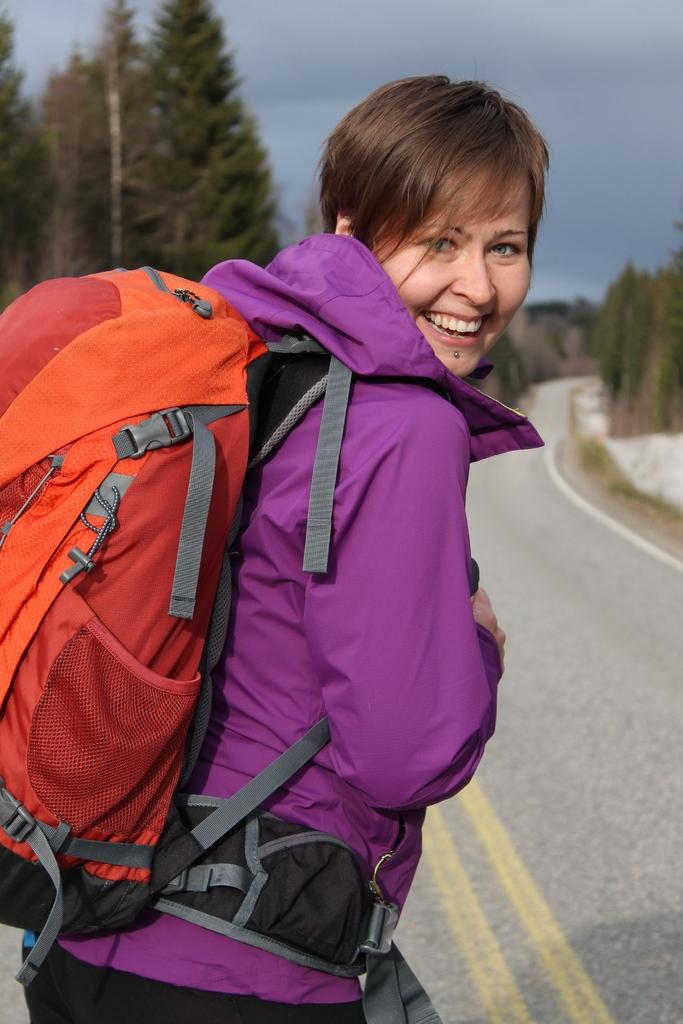Who is present in the image? There is a woman in the image. What is the woman carrying on her back? The woman is wearing a backpack. What can be seen in the background of the image? There is a road, a tree, and the sky visible in the background of the image. How many children are crying near the tree in the image? There are no children or crying present in the image. What type of brick is used to build the tree in the image? There is no brick used to build the tree in the image; it is a natural tree. 